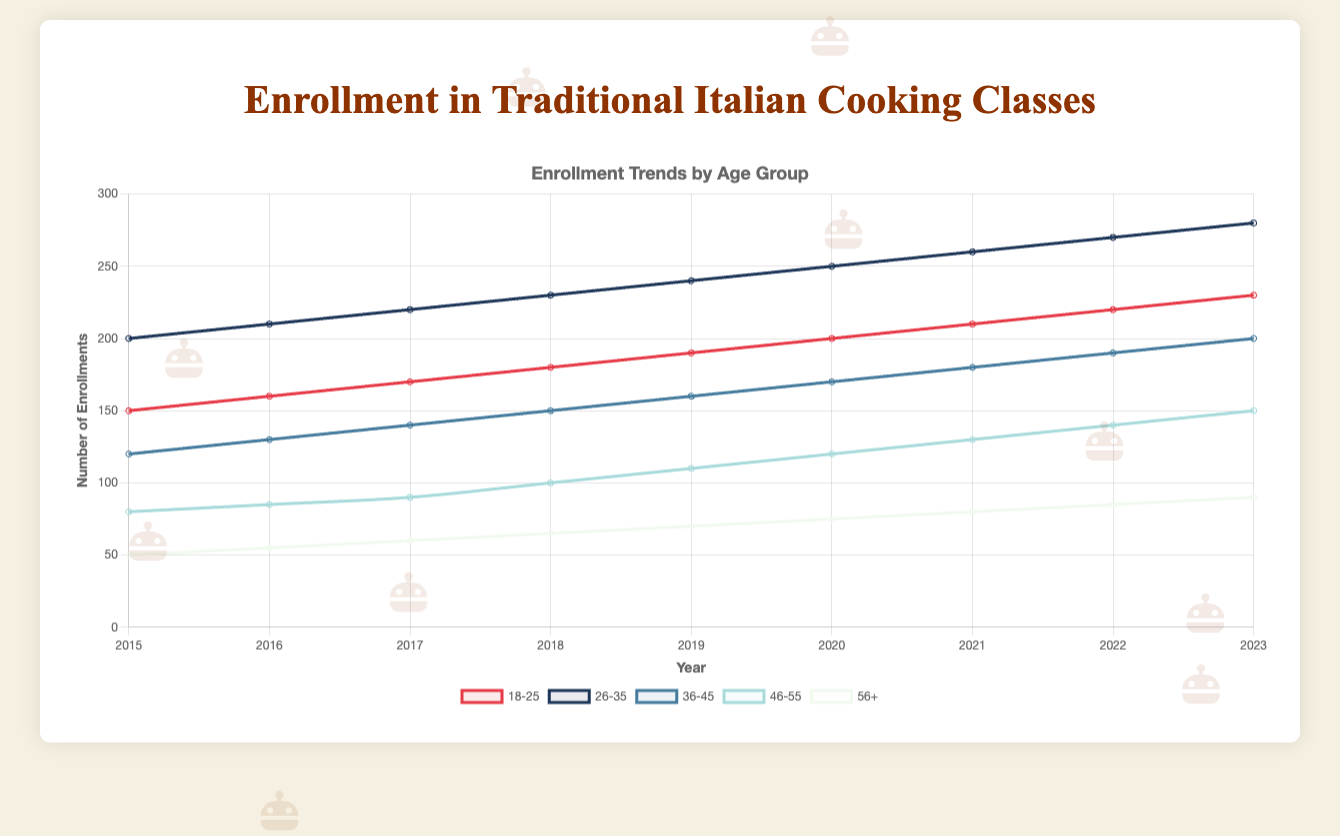what is the total enrollment in 2017 across all age groups? To find the total number of enrollments across all age groups in 2017, sum the enrollments in each age group: 170 (18-25) + 220 (26-35) + 140 (36-45) + 90 (46-55) + 60 (56+). The total is 170 + 220 + 140 + 90 + 60 = 680 enrollments
Answer: 680 which age group had the highest enrollment in 2020? Observing the data for 2020, the age groups have the following enrollments: 18-25 (200), 26-35 (250), 36-45 (170), 46-55 (120), 56+ (75). The highest enrollment is in the 26-35 age group, with 250 enrollments
Answer: 26-35 compare the enrollment trends for age group 18-25 and age group 56+ from 2015 to 2023. which group shows a steeper increase? To compare the trends, calculate the difference in enrollment from 2015 to 2023 for both groups. For 18-25: 230 (2023) - 150 (2015) = 80. For 56+: 90 (2023) - 50 (2015) = 40. The 18-25 age group shows a steeper increase with a difference of 80 compared to 40 for the 56+ group
Answer: 18-25 which year had the lowest enrollment for the age group 46-55? By examining the enrollment data across the years, the age group 46-55 had the following enrollments: 2015 (80), 2016 (85), 2017 (90), 2018 (100), 2019 (110), 2020 (120), 2021 (130), 2022 (140), 2023 (150). The lowest enrollment is in 2015, with 80 enrollments
Answer: 2015 what is the average enrollment for the age group 36-45 over the entire period from 2015 to 2023? Calculate the average by summing the enrollments for 36-45 over the years and then dividing by the number of years: (120+130+140+150+160+170+180+190+200) / 9. The sum is 1340, so the average is 1340/9 ≈ 149
Answer: 149 which color represents the enrollment trends for the age group 56+ in the chart? By observing the legend in the chart, the color associated with the 56+ age group is represented by a white color line (or light color if the shade is used) across the plot
Answer: white compare the enrollment in 2023 among the age groups 36-45 and 46-55. which group had a higher number and by what margin? In 2023, the enrollments are 200 for 36-45 and 150 for 46-55. The 36-45 age group has a higher enrollment by 200 - 150 = 50
Answer: 36-45 by 50 calculate the total overall increase in enrollment for the age group 26-35 from 2015 to 2023. Find the difference in enrollment numbers for 26-35 between 2015 and 2023: 280 (2023) - 200 (2015) = 80. Hence, the total increase is 80
Answer: 80 